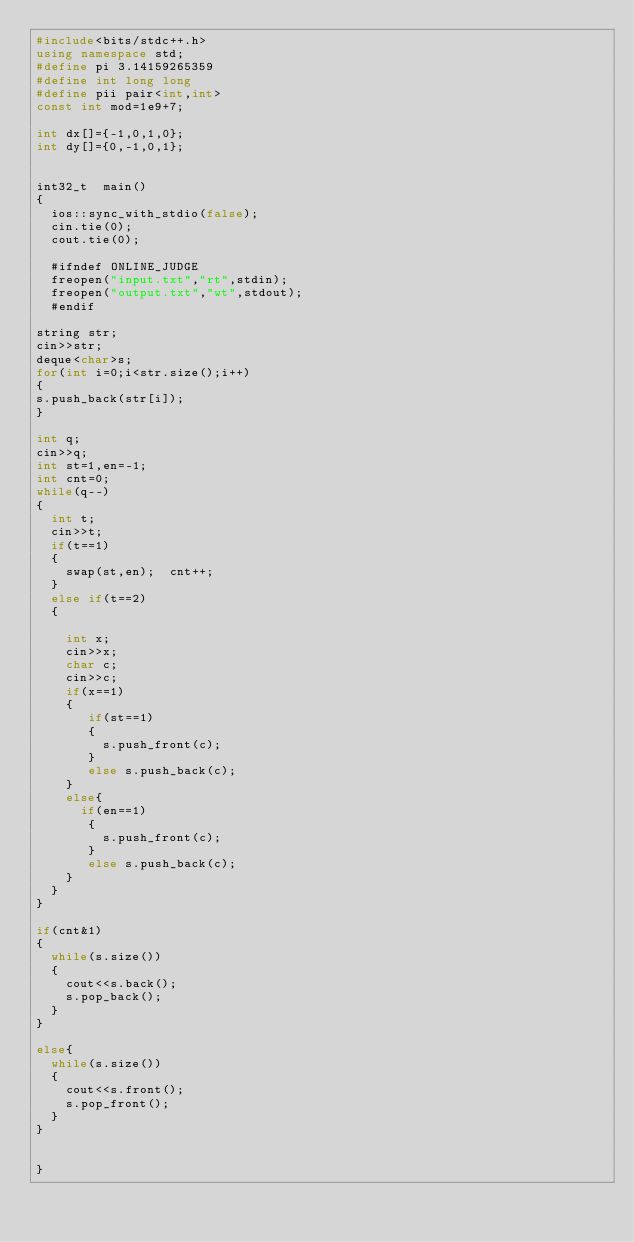Convert code to text. <code><loc_0><loc_0><loc_500><loc_500><_C++_>#include<bits/stdc++.h>
using namespace std;
#define pi 3.14159265359
#define int long long
#define pii pair<int,int>
const int mod=1e9+7;

int dx[]={-1,0,1,0};
int dy[]={0,-1,0,1};


int32_t  main()
{ 
  ios::sync_with_stdio(false);
  cin.tie(0);
  cout.tie(0);
 
  #ifndef ONLINE_JUDGE
  freopen("input.txt","rt",stdin);
  freopen("output.txt","wt",stdout);
  #endif

string str;
cin>>str;
deque<char>s;
for(int i=0;i<str.size();i++)
{
s.push_back(str[i]);
}

int q;
cin>>q;
int st=1,en=-1;
int cnt=0;
while(q--)
{
  int t;
  cin>>t;
  if(t==1)
  {
    swap(st,en);  cnt++;
  }
  else if(t==2)
  {
   
    int x;
    cin>>x;
    char c;
    cin>>c;
    if(x==1)
    {
       if(st==1)
       {
         s.push_front(c);
       }
       else s.push_back(c);
    }
    else{
      if(en==1)
       {
         s.push_front(c);
       }
       else s.push_back(c);
    }
  }
}

if(cnt&1)
{
  while(s.size())
  {
    cout<<s.back();
    s.pop_back();
  }
}

else{
  while(s.size())
  {
    cout<<s.front();
    s.pop_front();
  }
}

  
}

</code> 